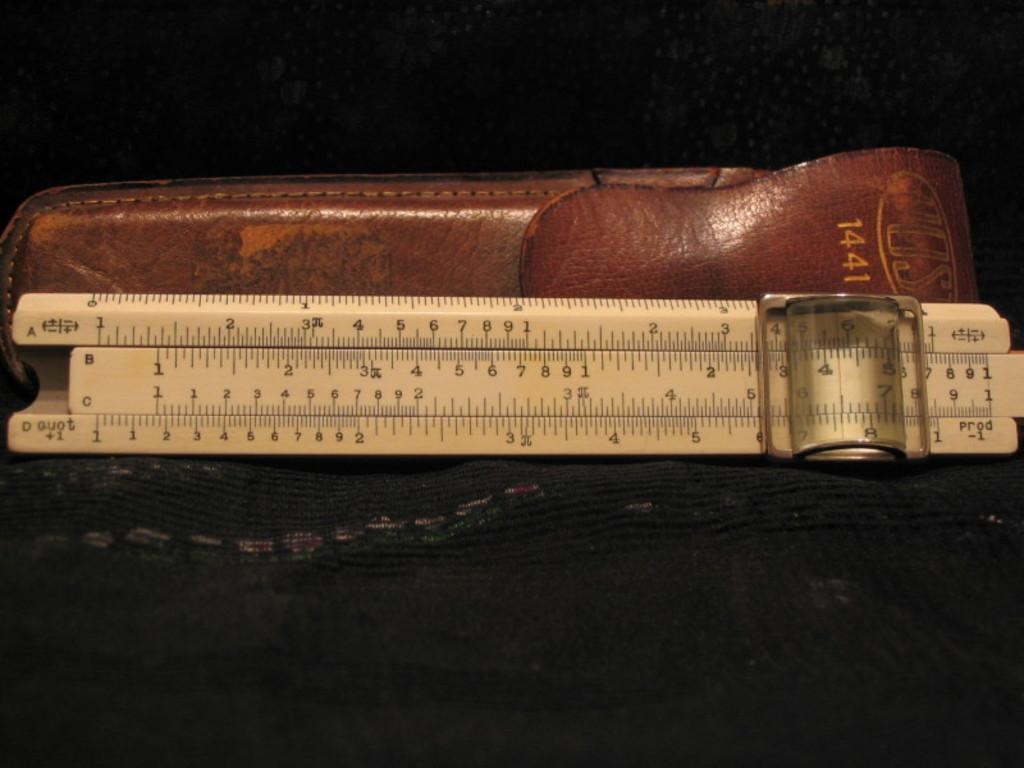<image>
Create a compact narrative representing the image presented. A leather case labeled 1441 sits behind a measuring device. 